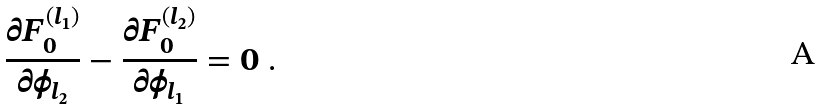<formula> <loc_0><loc_0><loc_500><loc_500>\frac { \partial F ^ { ( l _ { 1 } ) } _ { 0 } } { \partial \phi _ { l _ { 2 } } } - \frac { \partial F ^ { ( l _ { 2 } ) } _ { 0 } } { \partial \phi _ { l _ { 1 } } } = 0 \ .</formula> 